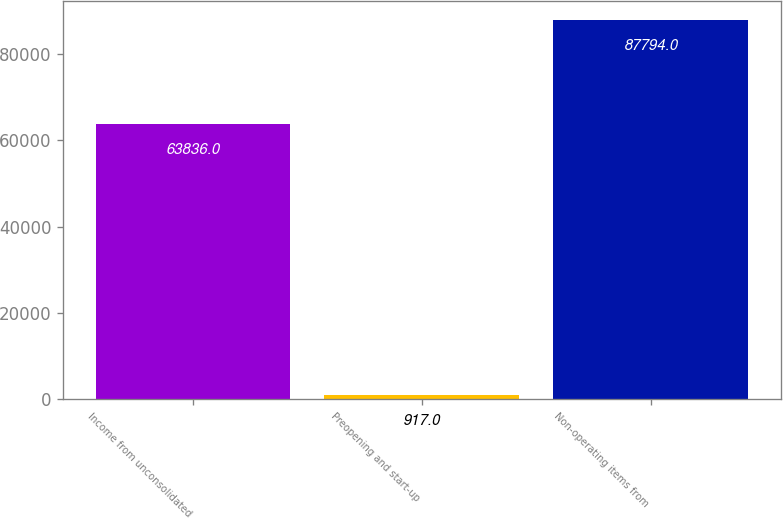<chart> <loc_0><loc_0><loc_500><loc_500><bar_chart><fcel>Income from unconsolidated<fcel>Preopening and start-up<fcel>Non-operating items from<nl><fcel>63836<fcel>917<fcel>87794<nl></chart> 